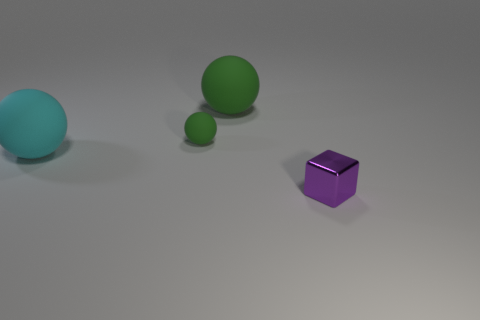What shape is the large thing that is made of the same material as the large green sphere?
Ensure brevity in your answer.  Sphere. Does the big green object have the same material as the small object that is in front of the big cyan ball?
Keep it short and to the point. No. There is a big rubber thing to the left of the large green thing; are there any small green rubber objects that are left of it?
Make the answer very short. No. There is another green thing that is the same shape as the big green matte object; what is it made of?
Ensure brevity in your answer.  Rubber. What number of matte objects are in front of the big green matte thing that is on the right side of the cyan rubber ball?
Your answer should be compact. 2. Is there anything else that is the same color as the tiny metallic object?
Provide a succinct answer. No. What number of things are either big green matte objects or big balls behind the small matte object?
Give a very brief answer. 1. There is a big sphere behind the big ball in front of the green rubber sphere left of the big green rubber ball; what is its material?
Offer a very short reply. Rubber. There is a cyan object that is the same material as the small ball; what is its size?
Give a very brief answer. Large. There is a tiny object to the right of the tiny thing behind the purple shiny object; what is its color?
Keep it short and to the point. Purple. 